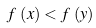<formula> <loc_0><loc_0><loc_500><loc_500>f \, \left ( x \right ) < f \, \left ( y \right )</formula> 